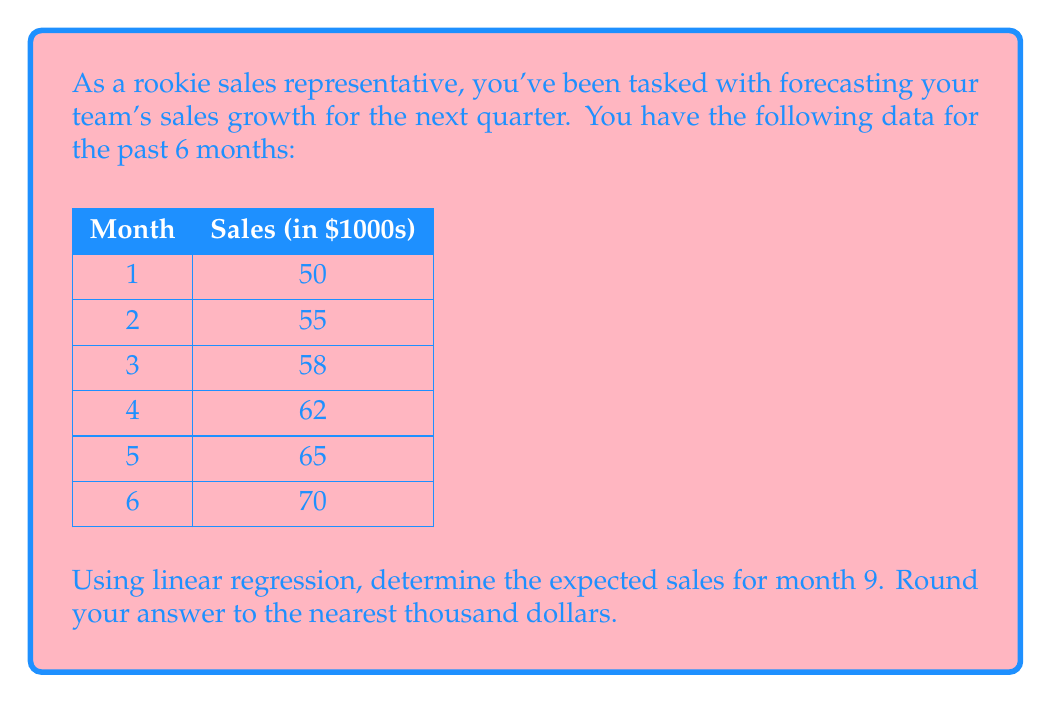What is the answer to this math problem? To solve this problem using linear regression, we'll follow these steps:

1. Calculate the means of x (months) and y (sales):
   $\bar{x} = \frac{1 + 2 + 3 + 4 + 5 + 6}{6} = 3.5$
   $\bar{y} = \frac{50 + 55 + 58 + 62 + 65 + 70}{6} = 60$

2. Calculate the slope (m) using the formula:
   $$m = \frac{\sum(x_i - \bar{x})(y_i - \bar{y})}{\sum(x_i - \bar{x})^2}$$

   Let's calculate the numerator and denominator separately:

   Numerator: $(1-3.5)(50-60) + (2-3.5)(55-60) + (3-3.5)(58-60) + (4-3.5)(62-60) + (5-3.5)(65-60) + (6-3.5)(70-60)$
             $= 12.5 + 2.5 + 1 + 3 + 12.5 + 25 = 56.5$

   Denominator: $(1-3.5)^2 + (2-3.5)^2 + (3-3.5)^2 + (4-3.5)^2 + (5-3.5)^2 + (6-3.5)^2$
               $= 6.25 + 2.25 + 0.25 + 0.25 + 2.25 + 6.25 = 17.5$

   $m = \frac{56.5}{17.5} = 3.23$

3. Calculate the y-intercept (b) using the formula:
   $b = \bar{y} - m\bar{x}$
   $b = 60 - 3.23 * 3.5 = 48.695$

4. The linear regression equation is:
   $y = mx + b$
   $y = 3.23x + 48.695$

5. To find the expected sales for month 9, plug in x = 9:
   $y = 3.23 * 9 + 48.695 = 77.765$

6. Rounding to the nearest thousand:
   $77.765 * 1000 \approx 78,000$
Answer: $78,000 